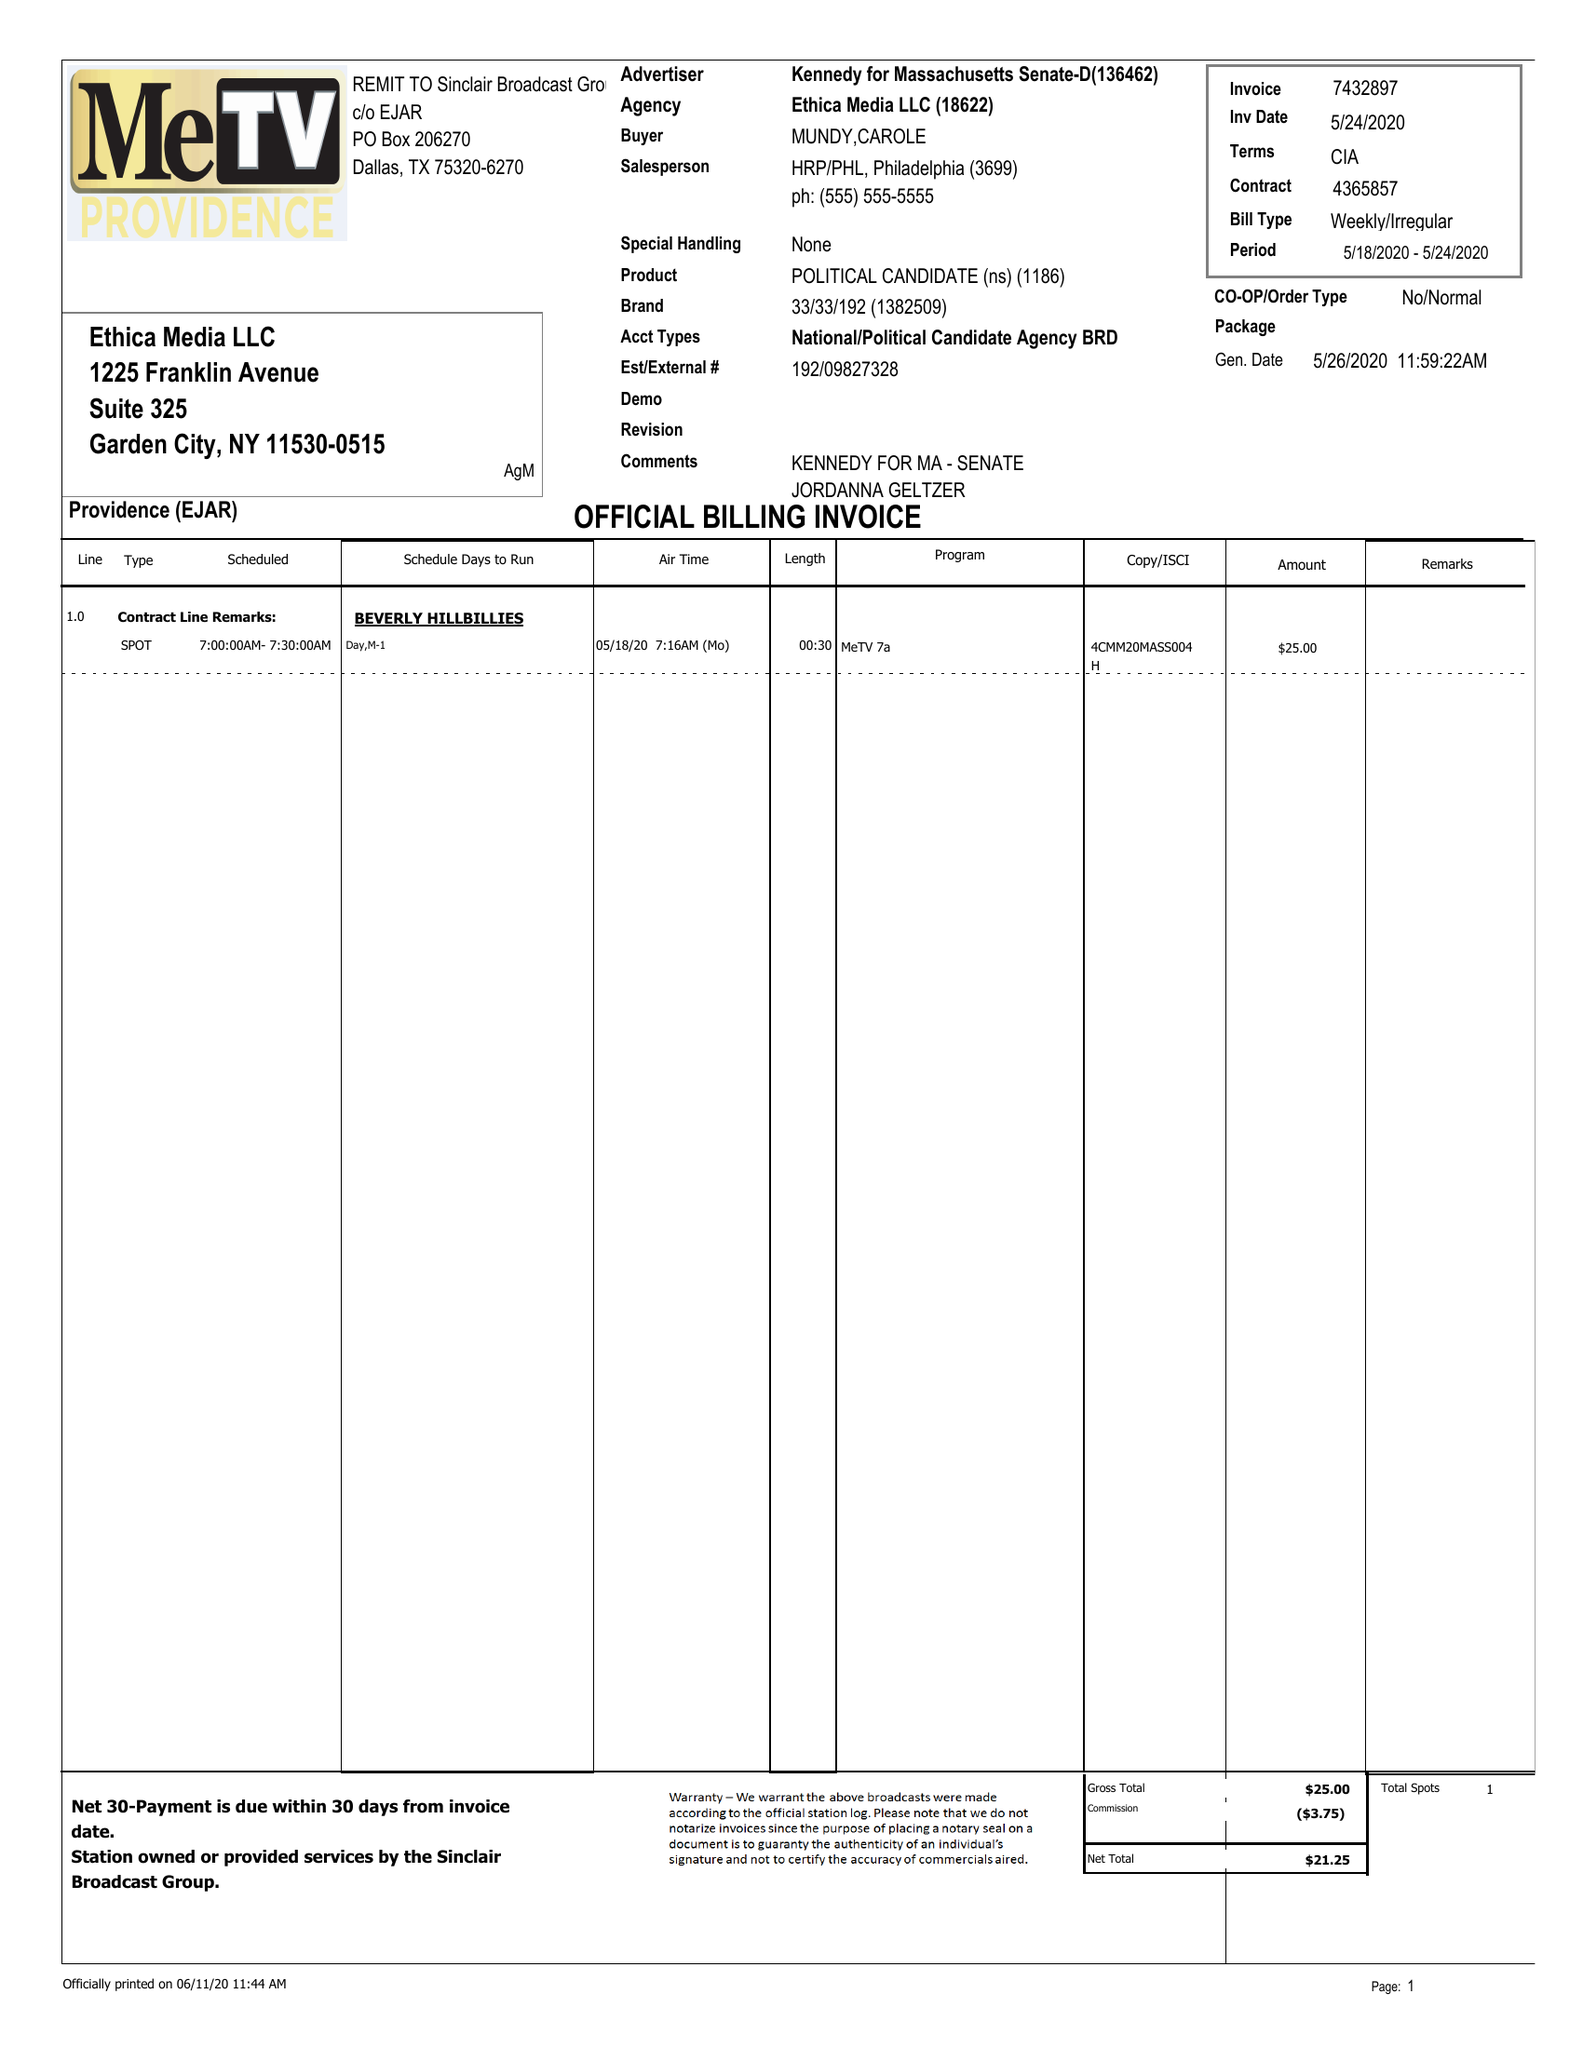What is the value for the advertiser?
Answer the question using a single word or phrase. KENNEDY FOR MASSACHUSETTS SENATE-D 